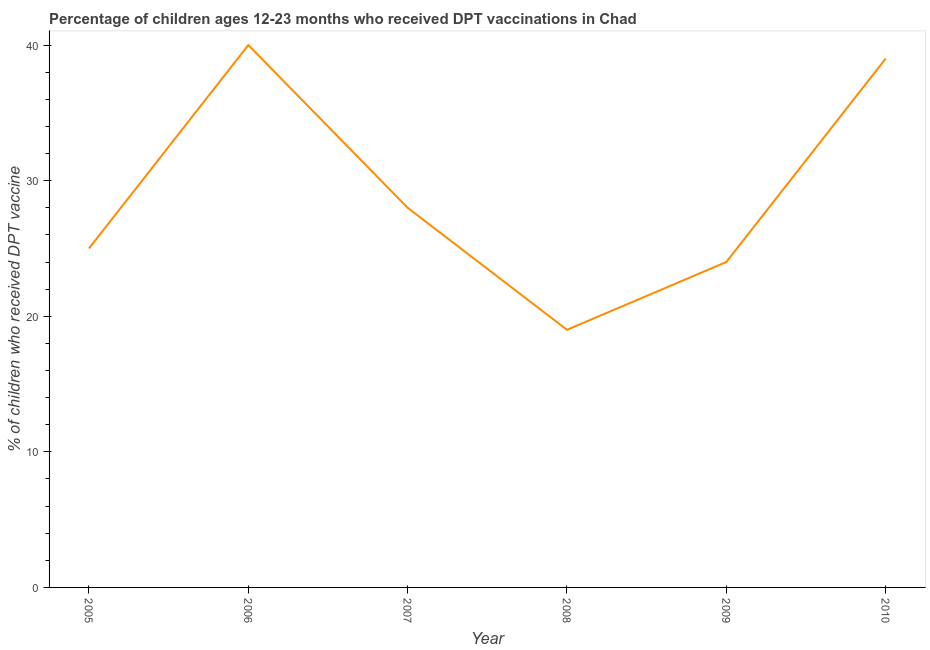What is the percentage of children who received dpt vaccine in 2006?
Make the answer very short. 40. Across all years, what is the maximum percentage of children who received dpt vaccine?
Offer a terse response. 40. Across all years, what is the minimum percentage of children who received dpt vaccine?
Offer a very short reply. 19. In which year was the percentage of children who received dpt vaccine maximum?
Provide a short and direct response. 2006. In which year was the percentage of children who received dpt vaccine minimum?
Ensure brevity in your answer.  2008. What is the sum of the percentage of children who received dpt vaccine?
Ensure brevity in your answer.  175. What is the difference between the percentage of children who received dpt vaccine in 2009 and 2010?
Your answer should be compact. -15. What is the average percentage of children who received dpt vaccine per year?
Your answer should be compact. 29.17. What is the median percentage of children who received dpt vaccine?
Ensure brevity in your answer.  26.5. What is the ratio of the percentage of children who received dpt vaccine in 2006 to that in 2007?
Ensure brevity in your answer.  1.43. What is the difference between the highest and the second highest percentage of children who received dpt vaccine?
Your response must be concise. 1. Is the sum of the percentage of children who received dpt vaccine in 2006 and 2009 greater than the maximum percentage of children who received dpt vaccine across all years?
Make the answer very short. Yes. What is the difference between the highest and the lowest percentage of children who received dpt vaccine?
Provide a succinct answer. 21. Does the percentage of children who received dpt vaccine monotonically increase over the years?
Ensure brevity in your answer.  No. How many years are there in the graph?
Make the answer very short. 6. What is the difference between two consecutive major ticks on the Y-axis?
Give a very brief answer. 10. Are the values on the major ticks of Y-axis written in scientific E-notation?
Keep it short and to the point. No. What is the title of the graph?
Ensure brevity in your answer.  Percentage of children ages 12-23 months who received DPT vaccinations in Chad. What is the label or title of the Y-axis?
Keep it short and to the point. % of children who received DPT vaccine. What is the % of children who received DPT vaccine in 2006?
Offer a very short reply. 40. What is the % of children who received DPT vaccine of 2007?
Your response must be concise. 28. What is the difference between the % of children who received DPT vaccine in 2005 and 2006?
Provide a succinct answer. -15. What is the difference between the % of children who received DPT vaccine in 2005 and 2008?
Offer a very short reply. 6. What is the difference between the % of children who received DPT vaccine in 2005 and 2009?
Offer a very short reply. 1. What is the difference between the % of children who received DPT vaccine in 2005 and 2010?
Offer a terse response. -14. What is the difference between the % of children who received DPT vaccine in 2006 and 2007?
Your answer should be very brief. 12. What is the difference between the % of children who received DPT vaccine in 2006 and 2010?
Make the answer very short. 1. What is the difference between the % of children who received DPT vaccine in 2007 and 2008?
Provide a succinct answer. 9. What is the difference between the % of children who received DPT vaccine in 2007 and 2009?
Provide a short and direct response. 4. What is the difference between the % of children who received DPT vaccine in 2008 and 2010?
Offer a terse response. -20. What is the difference between the % of children who received DPT vaccine in 2009 and 2010?
Provide a short and direct response. -15. What is the ratio of the % of children who received DPT vaccine in 2005 to that in 2007?
Offer a very short reply. 0.89. What is the ratio of the % of children who received DPT vaccine in 2005 to that in 2008?
Offer a very short reply. 1.32. What is the ratio of the % of children who received DPT vaccine in 2005 to that in 2009?
Make the answer very short. 1.04. What is the ratio of the % of children who received DPT vaccine in 2005 to that in 2010?
Make the answer very short. 0.64. What is the ratio of the % of children who received DPT vaccine in 2006 to that in 2007?
Provide a succinct answer. 1.43. What is the ratio of the % of children who received DPT vaccine in 2006 to that in 2008?
Give a very brief answer. 2.1. What is the ratio of the % of children who received DPT vaccine in 2006 to that in 2009?
Give a very brief answer. 1.67. What is the ratio of the % of children who received DPT vaccine in 2007 to that in 2008?
Your answer should be very brief. 1.47. What is the ratio of the % of children who received DPT vaccine in 2007 to that in 2009?
Make the answer very short. 1.17. What is the ratio of the % of children who received DPT vaccine in 2007 to that in 2010?
Offer a very short reply. 0.72. What is the ratio of the % of children who received DPT vaccine in 2008 to that in 2009?
Keep it short and to the point. 0.79. What is the ratio of the % of children who received DPT vaccine in 2008 to that in 2010?
Ensure brevity in your answer.  0.49. What is the ratio of the % of children who received DPT vaccine in 2009 to that in 2010?
Your answer should be very brief. 0.61. 